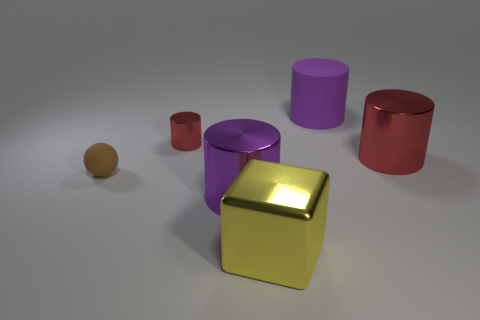There is a metallic object that is the same color as the large matte object; what is its size?
Ensure brevity in your answer.  Large. Are there the same number of yellow cubes behind the large rubber object and big metal blocks left of the small shiny cylinder?
Give a very brief answer. Yes. There is a ball; is its size the same as the red object that is left of the yellow shiny block?
Ensure brevity in your answer.  Yes. There is a big purple cylinder that is behind the large red metal cylinder; is there a shiny cylinder on the right side of it?
Ensure brevity in your answer.  Yes. Is there a large yellow metallic object that has the same shape as the big purple matte thing?
Give a very brief answer. No. There is a big purple object that is behind the brown thing that is to the left of the large metal block; how many big cylinders are right of it?
Offer a very short reply. 1. Does the large rubber cylinder have the same color as the big shiny thing that is on the left side of the big yellow thing?
Your answer should be very brief. Yes. What number of things are large things in front of the large purple matte thing or big cylinders that are behind the big red cylinder?
Make the answer very short. 4. Is the number of metal objects in front of the rubber sphere greater than the number of tiny brown rubber objects behind the small metallic cylinder?
Your response must be concise. Yes. What is the material of the big purple thing behind the big purple cylinder in front of the red shiny object that is behind the big red shiny cylinder?
Provide a short and direct response. Rubber. 